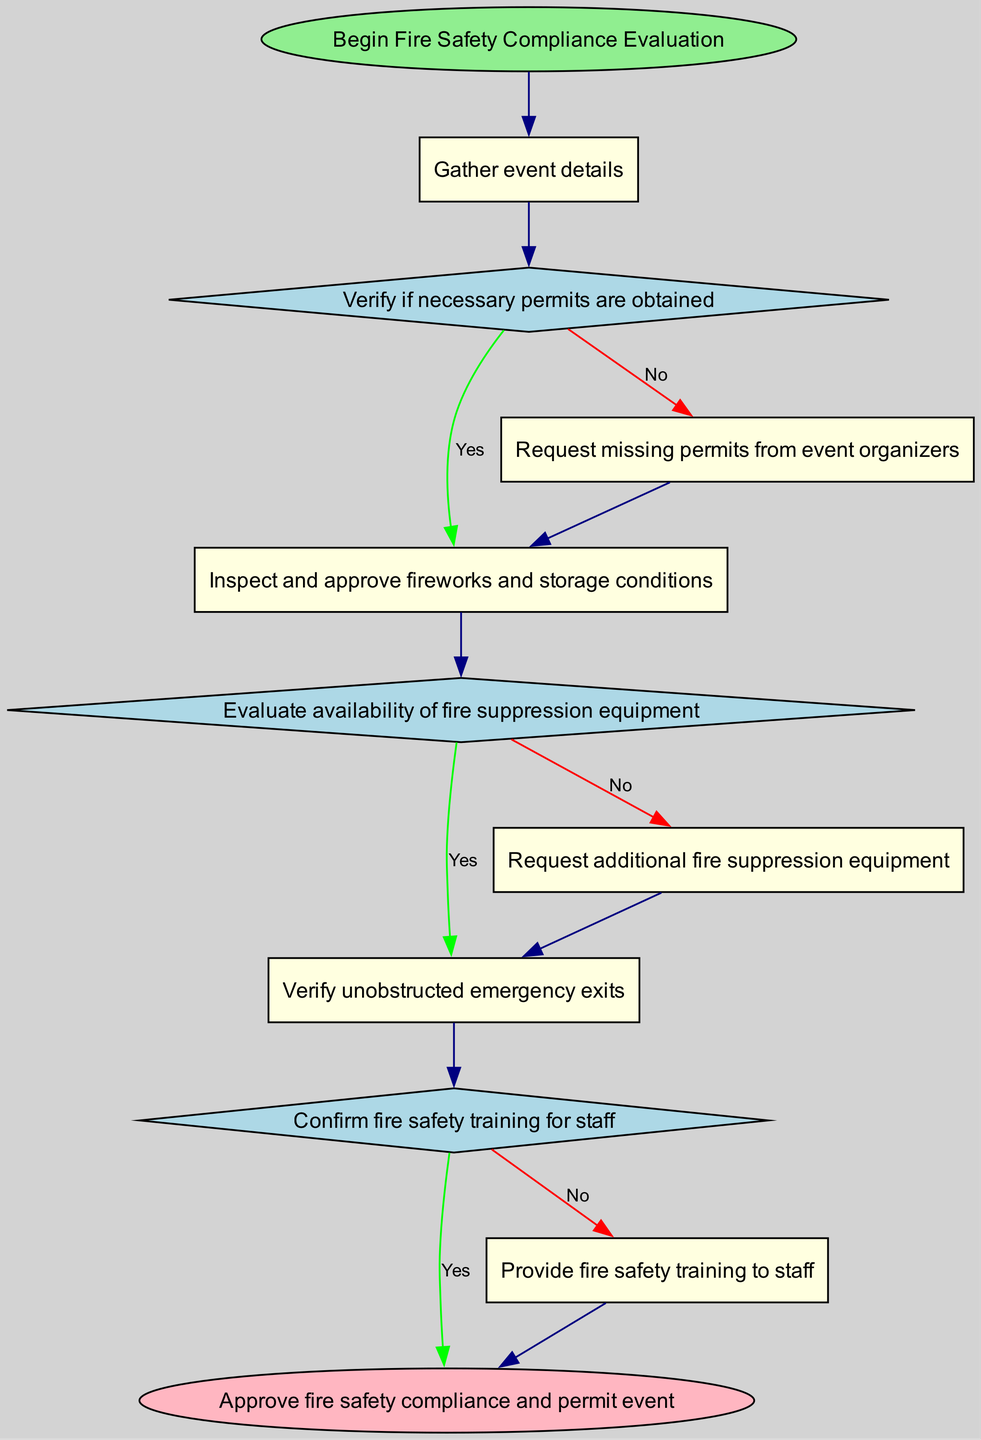What is the first step in the fire safety compliance evaluation? The first step is indicated by the 'start' node, which states that the process begins with "Begin Fire Safety Compliance Evaluation." This is the initial action to take before proceeding to gather event details.
Answer: Begin Fire Safety Compliance Evaluation How many decision nodes are there in the diagram? The diagram contains three decision nodes: "Verify if necessary permits are obtained," "Evaluate availability of fire suppression equipment," and "Confirm fire safety training for staff." These nodes guide the flow based on specific yes/no criteria.
Answer: 3 What is the next action after gathering event details? After gathering event details, the next action is to "Verify if necessary permits are obtained." This determines whether the event is compliant with local regulations regarding permits for fireworks displays.
Answer: Verify if necessary permits are obtained What happens if the necessary permits are not obtained? If the necessary permits are not obtained, the flow directs to "Request missing permits from event organizers." This step is taken to ensure compliance before proceeding further in the evaluation process.
Answer: Request missing permits from event organizers What action follows the request for additional fire suppression equipment? The action that follows the request for additional fire suppression equipment is to "Verify unobstructed emergency exits." Ensuring that exits are clear is crucial for safety in emergencies.
Answer: Verify unobstructed emergency exits How does the diagram address staff training requirements? The diagram addresses staff training requirements through the decision node "Confirm fire safety training for staff." If the training is confirmed as lacking, it leads to "Provide fire safety training to staff." This process ensures that all staff are adequately trained in fire safety protocols.
Answer: Provide fire safety training to staff What is the final outcome of the evaluation process? The final outcome of the evaluation process is to "Approve fire safety compliance and permit event." This indicates that all necessary safety measures and compliance checks have been successfully completed.
Answer: Approve fire safety compliance and permit event What is evaluated after inspecting fireworks? After inspecting fireworks, the next evaluation is of the "availability of fire suppression equipment." This ensures that adequate measures are in place to address any fire hazards during the event.
Answer: Evaluate availability of fire suppression equipment 